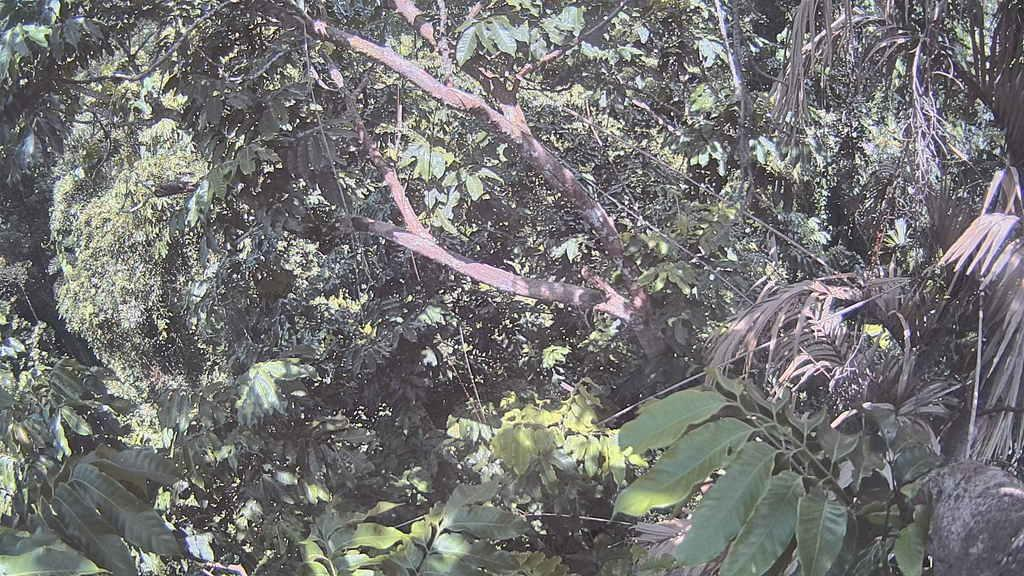What type of vegetation can be seen in the image? There are trees in the image. What else can be seen in the image besides trees? There are electric wires in the image. What is the color of the leaves on the trees in the image? Green leaves are present in the image. What type of rail can be seen in the image? There is no rail present in the image; it features trees and electric wires. What is the minister doing in the image? There is no minister present in the image. 